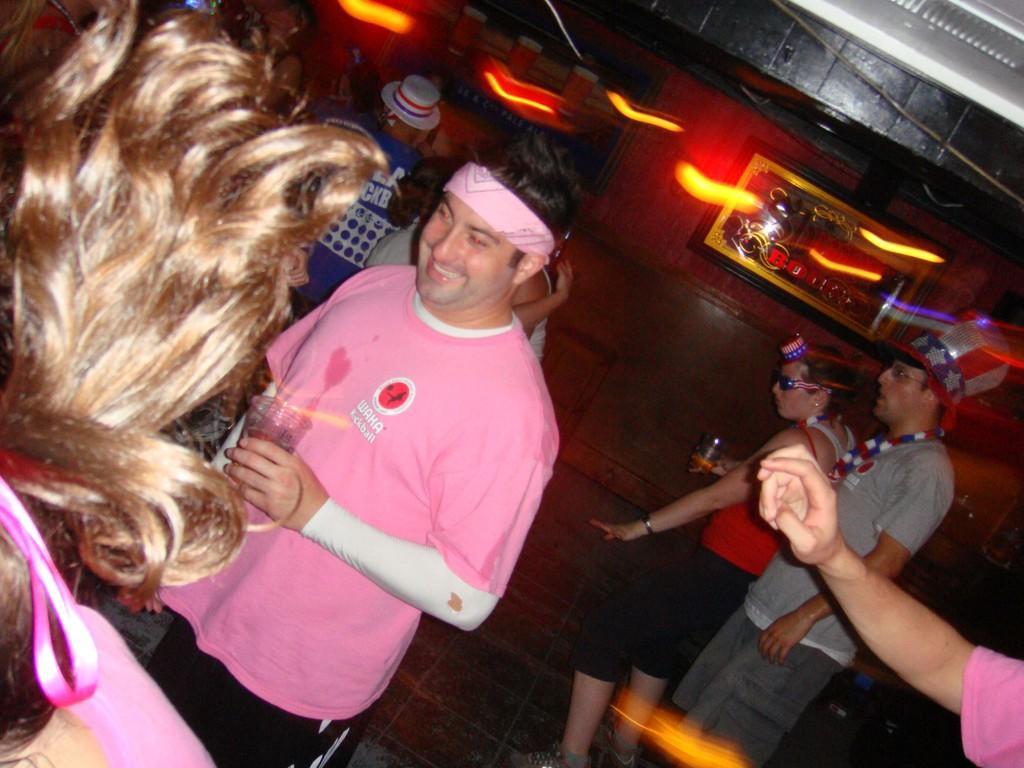Describe this image in one or two sentences. In this image we can see people standing on the floor. In the background we can see wall, frames, ceiling, and lights. On the right side of the image we can see hand of a person. 